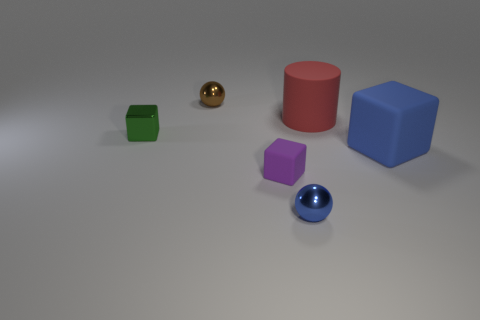Add 4 purple objects. How many objects exist? 10 Subtract 1 cylinders. How many cylinders are left? 0 Subtract all tiny cubes. How many cubes are left? 1 Subtract all balls. How many objects are left? 4 Subtract all red cubes. How many purple cylinders are left? 0 Subtract all brown objects. Subtract all green blocks. How many objects are left? 4 Add 3 purple things. How many purple things are left? 4 Add 1 rubber cylinders. How many rubber cylinders exist? 2 Subtract all purple cubes. How many cubes are left? 2 Subtract 0 brown cubes. How many objects are left? 6 